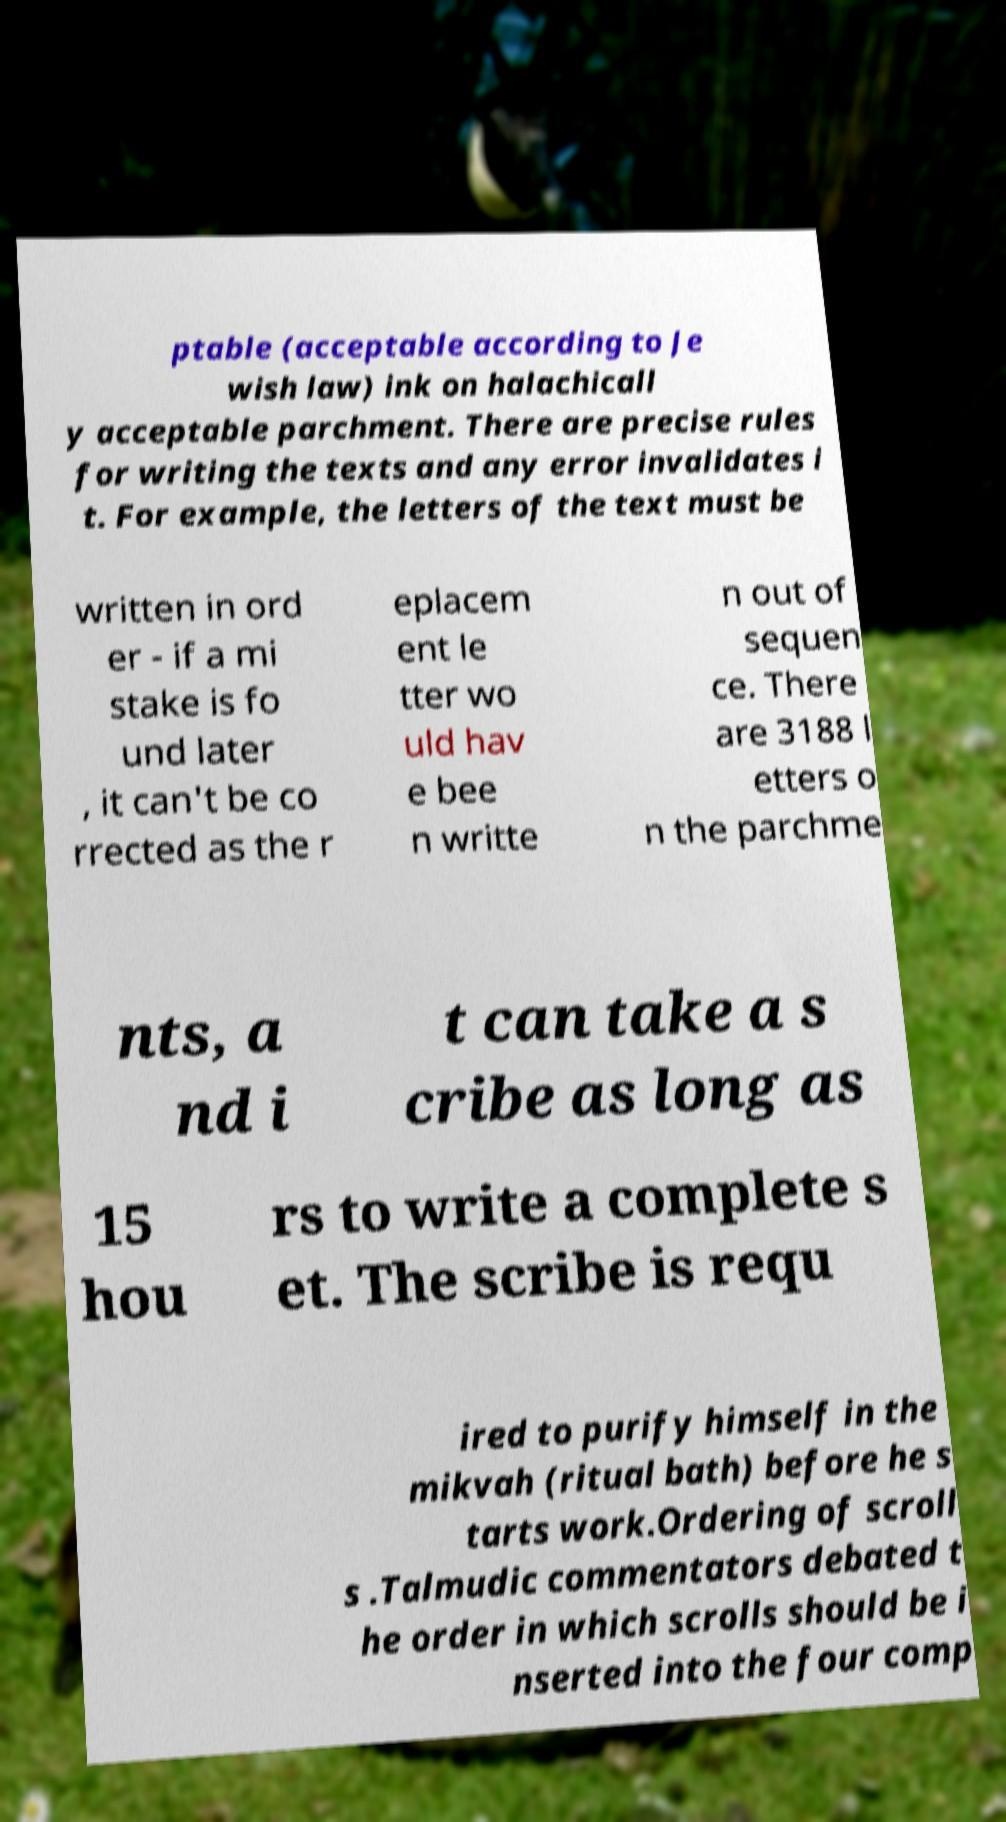Could you extract and type out the text from this image? ptable (acceptable according to Je wish law) ink on halachicall y acceptable parchment. There are precise rules for writing the texts and any error invalidates i t. For example, the letters of the text must be written in ord er - if a mi stake is fo und later , it can't be co rrected as the r eplacem ent le tter wo uld hav e bee n writte n out of sequen ce. There are 3188 l etters o n the parchme nts, a nd i t can take a s cribe as long as 15 hou rs to write a complete s et. The scribe is requ ired to purify himself in the mikvah (ritual bath) before he s tarts work.Ordering of scroll s .Talmudic commentators debated t he order in which scrolls should be i nserted into the four comp 